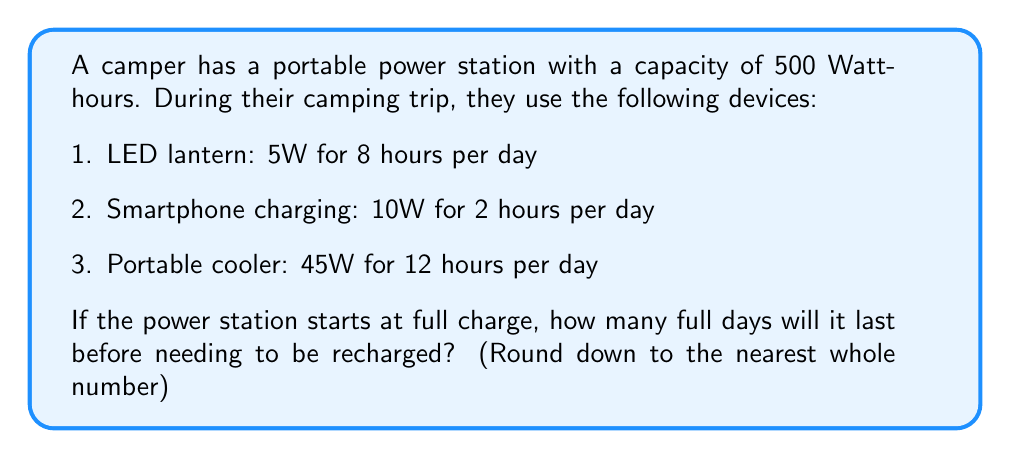Help me with this question. Let's approach this step-by-step:

1. Calculate the daily energy consumption for each device:
   - LED lantern: $5W \times 8h = 40Wh$
   - Smartphone charging: $10W \times 2h = 20Wh$
   - Portable cooler: $45W \times 12h = 540Wh$

2. Calculate the total daily energy consumption:
   $\text{Total daily consumption} = 40Wh + 20Wh + 540Wh = 600Wh$

3. Calculate how long the power station will last:
   $\text{Days of operation} = \frac{\text{Power station capacity}}{\text{Total daily consumption}}$
   
   $\text{Days of operation} = \frac{500Wh}{600Wh/day} \approx 0.8333 \text{ days}$

4. Round down to the nearest whole number:
   $\lfloor 0.8333 \rfloor = 0$

Therefore, the power station will not last a full day before needing to be recharged.
Answer: 0 days 